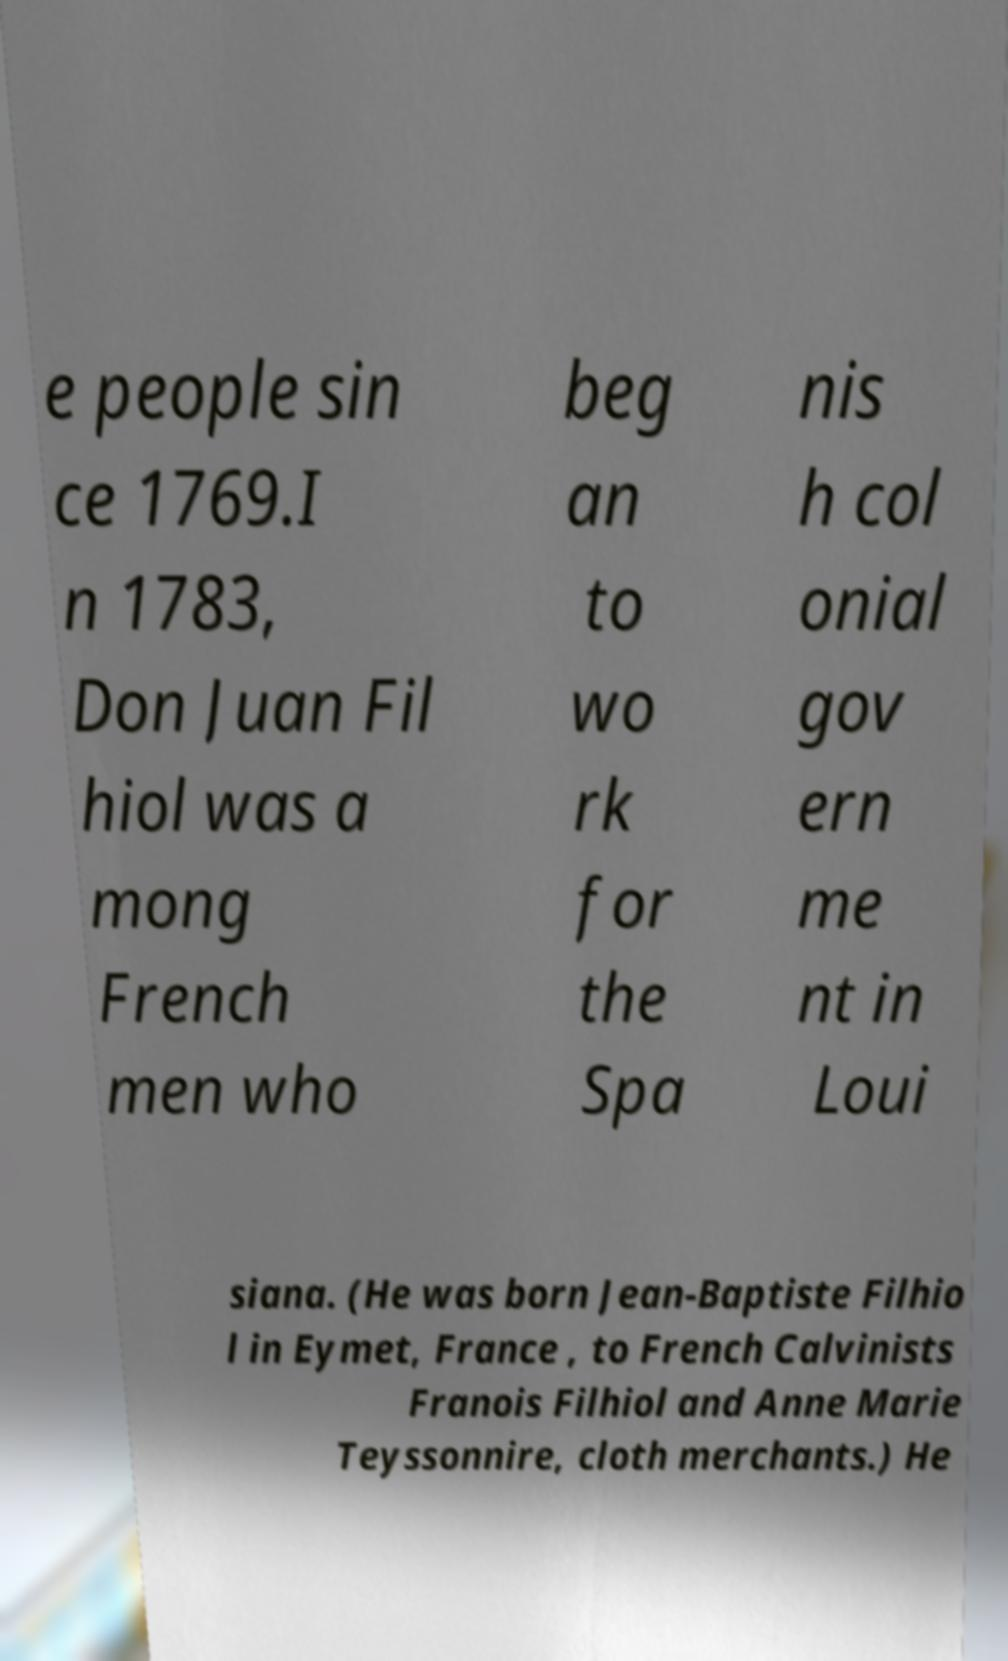Please read and relay the text visible in this image. What does it say? e people sin ce 1769.I n 1783, Don Juan Fil hiol was a mong French men who beg an to wo rk for the Spa nis h col onial gov ern me nt in Loui siana. (He was born Jean-Baptiste Filhio l in Eymet, France , to French Calvinists Franois Filhiol and Anne Marie Teyssonnire, cloth merchants.) He 